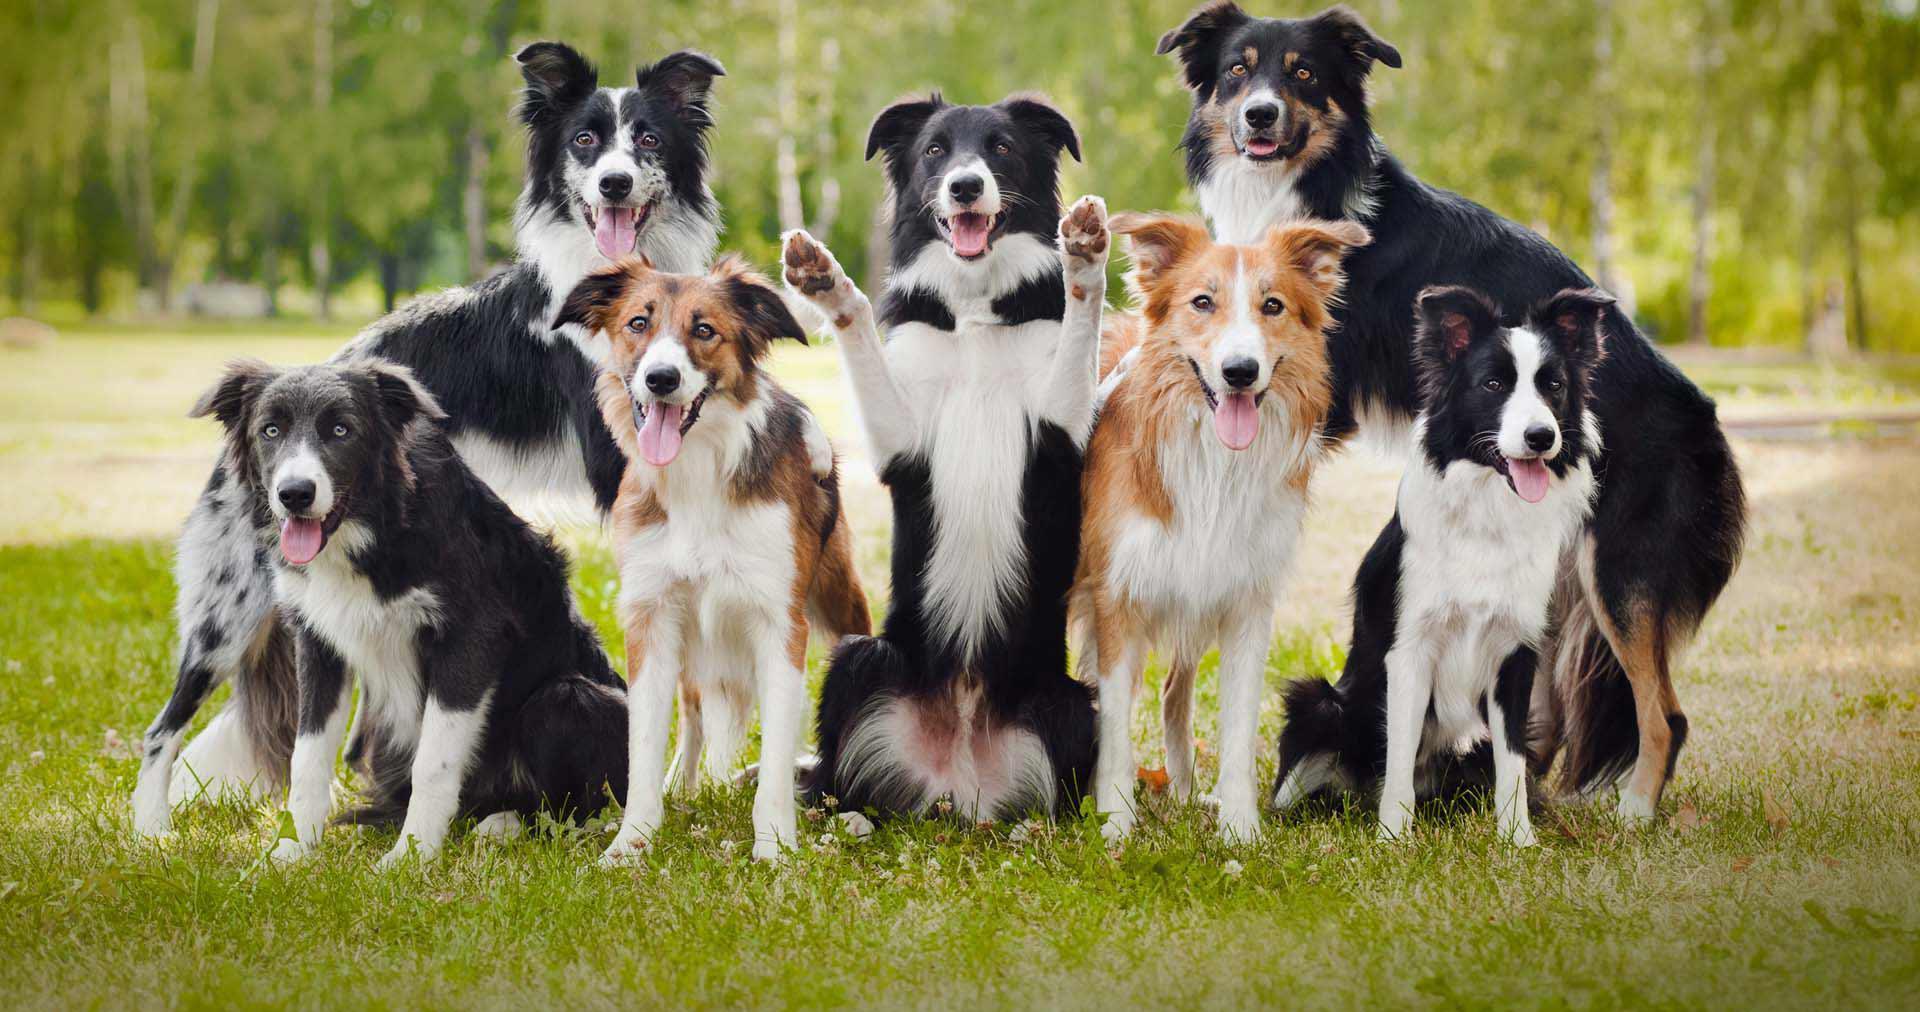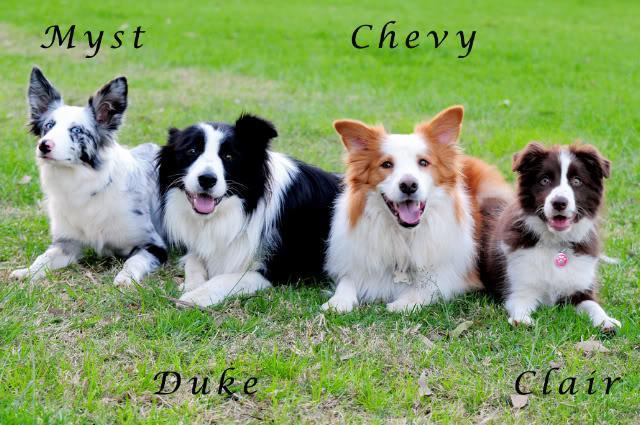The first image is the image on the left, the second image is the image on the right. Considering the images on both sides, is "There are three dogs in one picture and one dog in the other picture." valid? Answer yes or no. No. The first image is the image on the left, the second image is the image on the right. Assess this claim about the two images: "The dog in the image on the right is laying down with their face pointing forward.". Correct or not? Answer yes or no. No. 